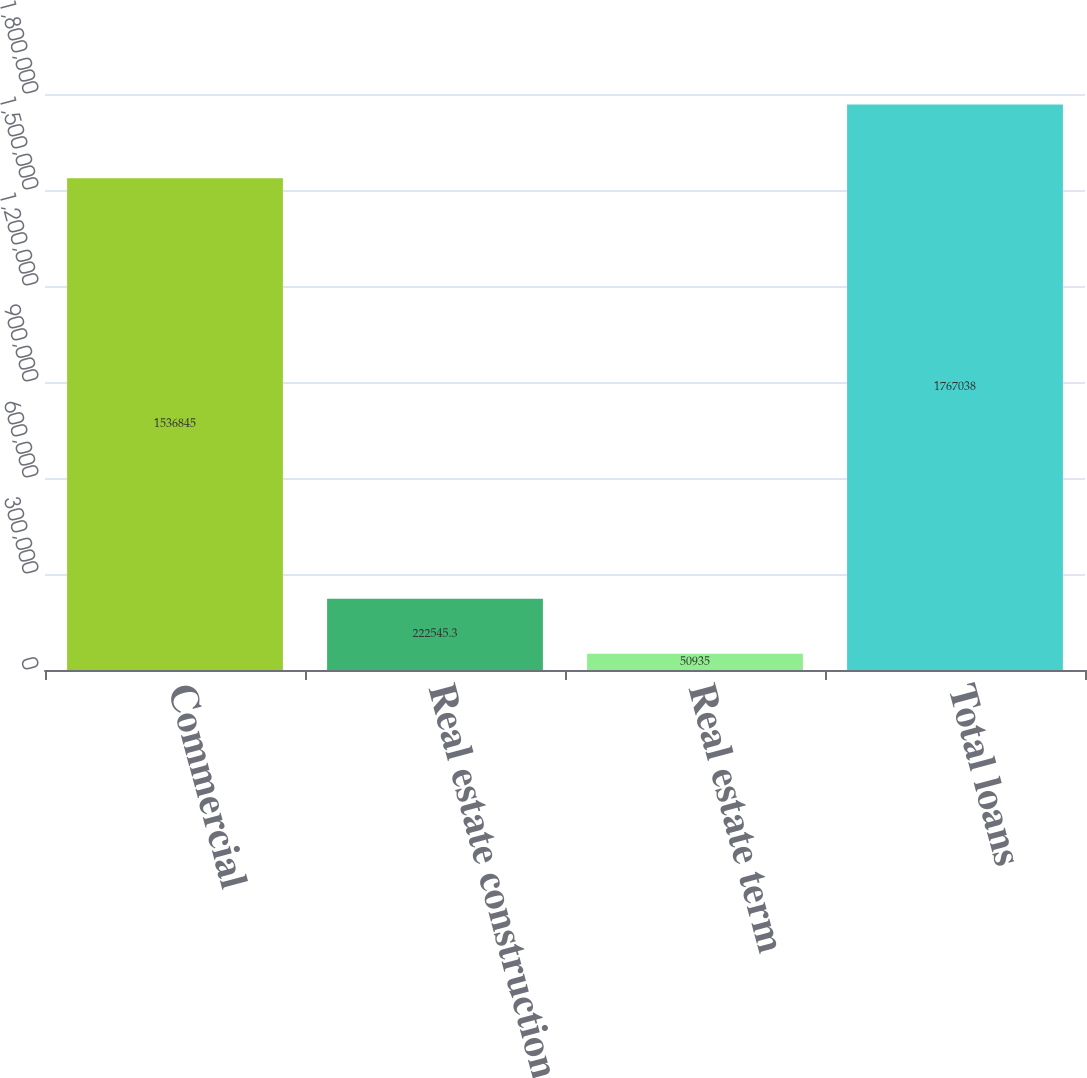Convert chart to OTSL. <chart><loc_0><loc_0><loc_500><loc_500><bar_chart><fcel>Commercial<fcel>Real estate construction<fcel>Real estate term<fcel>Total loans<nl><fcel>1.53684e+06<fcel>222545<fcel>50935<fcel>1.76704e+06<nl></chart> 